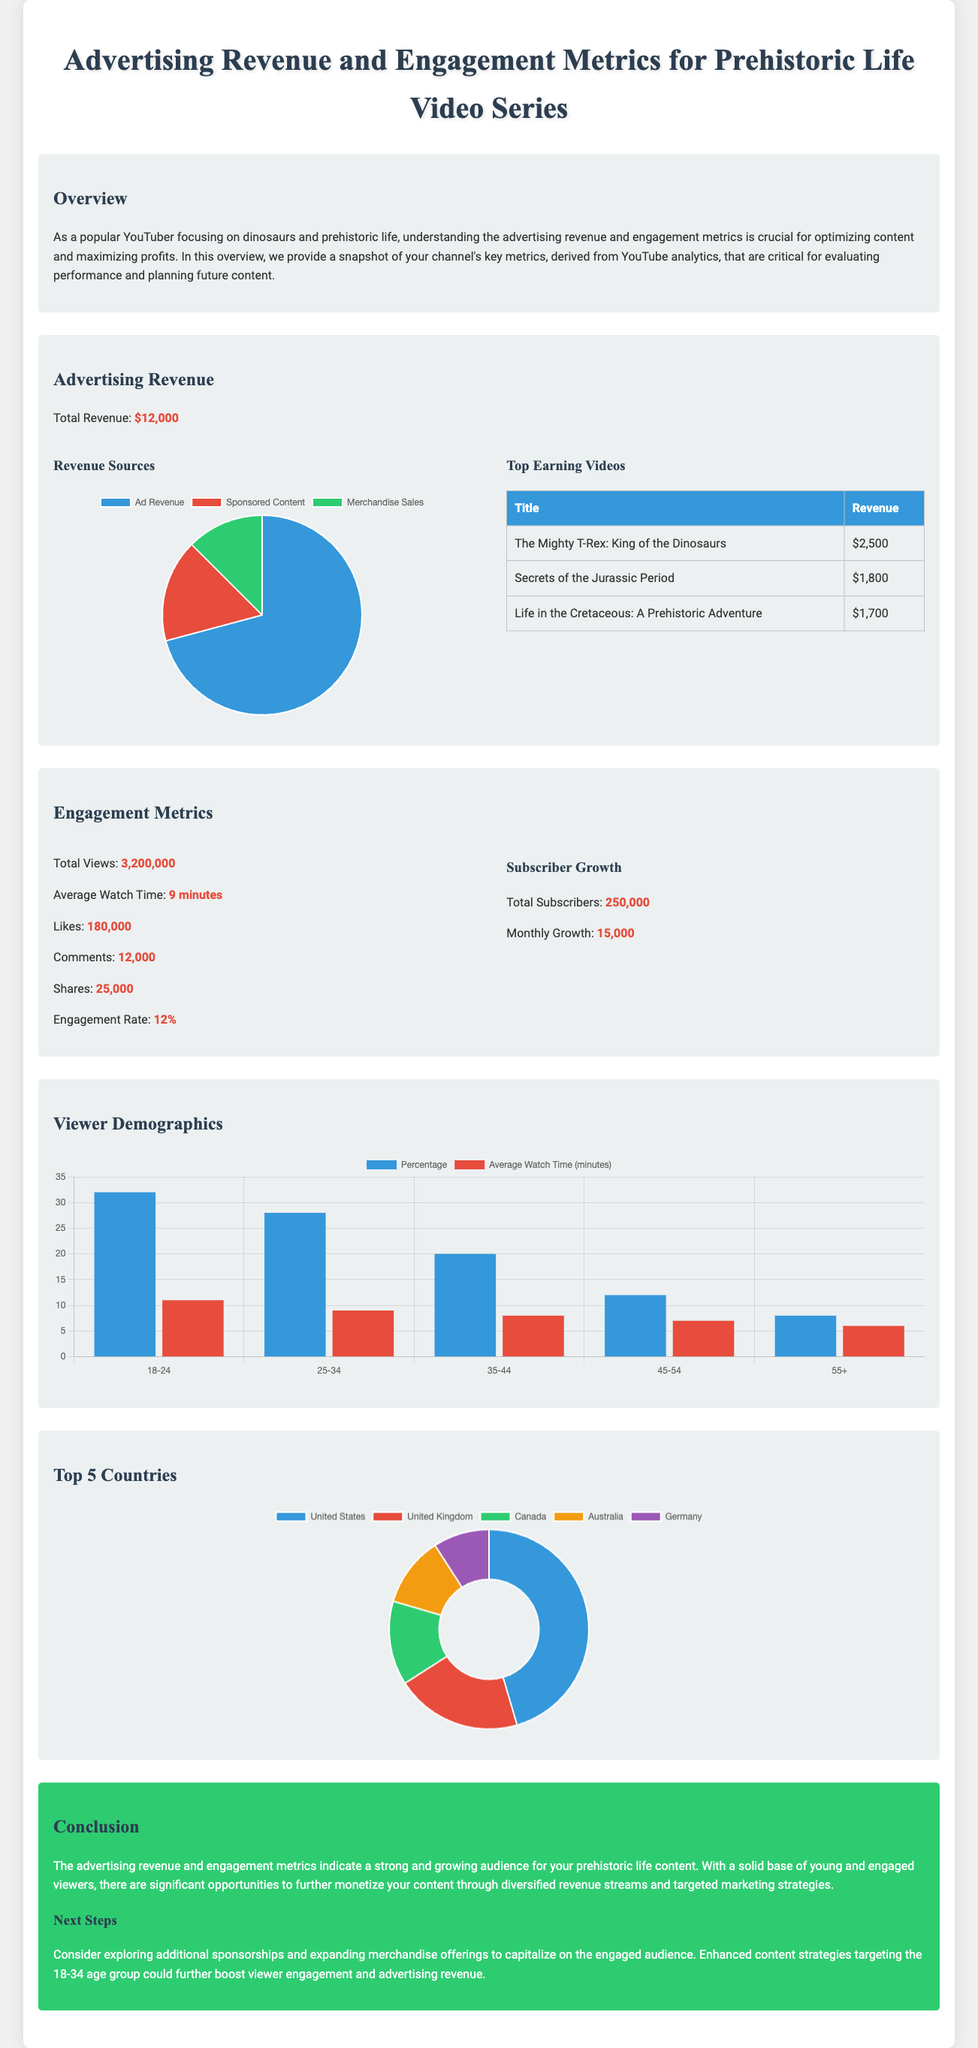what is the total revenue? The total revenue is stated in the document as $12,000.
Answer: $12,000 what is the average watch time? The average watch time is provided as 9 minutes in the engagement metrics section.
Answer: 9 minutes which video earned the highest revenue? The video with the highest revenue listed is "The Mighty T-Rex: King of the Dinosaurs," which earned $2,500.
Answer: The Mighty T-Rex: King of the Dinosaurs how many total subscribers are there? The total number of subscribers mentioned is 250,000.
Answer: 250,000 what percentage is the engagement rate? The engagement rate highlighted in the engagement metrics is 12%.
Answer: 12% which demographic group has the highest percentage? The demographic group with the highest percentage is 18-24.
Answer: 18-24 how many views were there in total? The document states that the total views recorded are 3,200,000.
Answer: 3,200,000 how much revenue does sponsored content generate? The revenue generated from sponsored content is $2,000 according to the revenue sources chart.
Answer: $2,000 what is the average watch time for the 25-34 age group? The average watch time for the 25-34 age group is 9 minutes, as shown in the demographics chart.
Answer: 9 minutes 